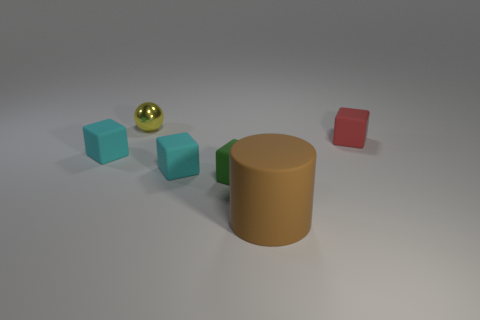Add 3 rubber cylinders. How many objects exist? 9 Subtract all balls. How many objects are left? 5 Add 5 balls. How many balls are left? 6 Add 1 big purple metal balls. How many big purple metal balls exist? 1 Subtract 1 green blocks. How many objects are left? 5 Subtract all red matte blocks. Subtract all big objects. How many objects are left? 4 